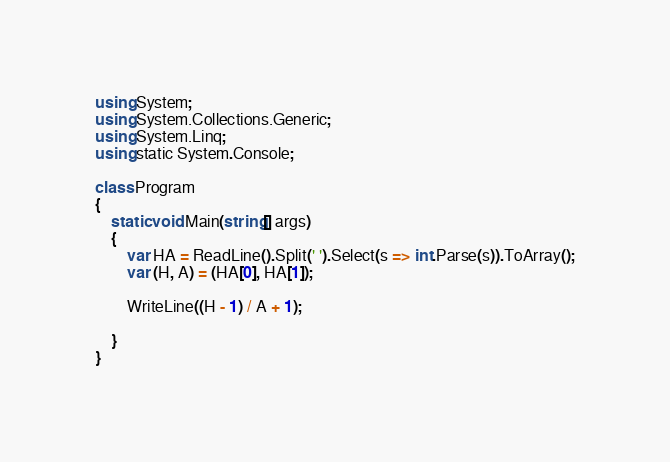<code> <loc_0><loc_0><loc_500><loc_500><_C#_>using System;
using System.Collections.Generic;
using System.Linq;
using static System.Console;

class Program
{
    static void Main(string[] args)
    {
        var HA = ReadLine().Split(' ').Select(s => int.Parse(s)).ToArray();
        var (H, A) = (HA[0], HA[1]);

        WriteLine((H - 1) / A + 1);

    }
}
</code> 